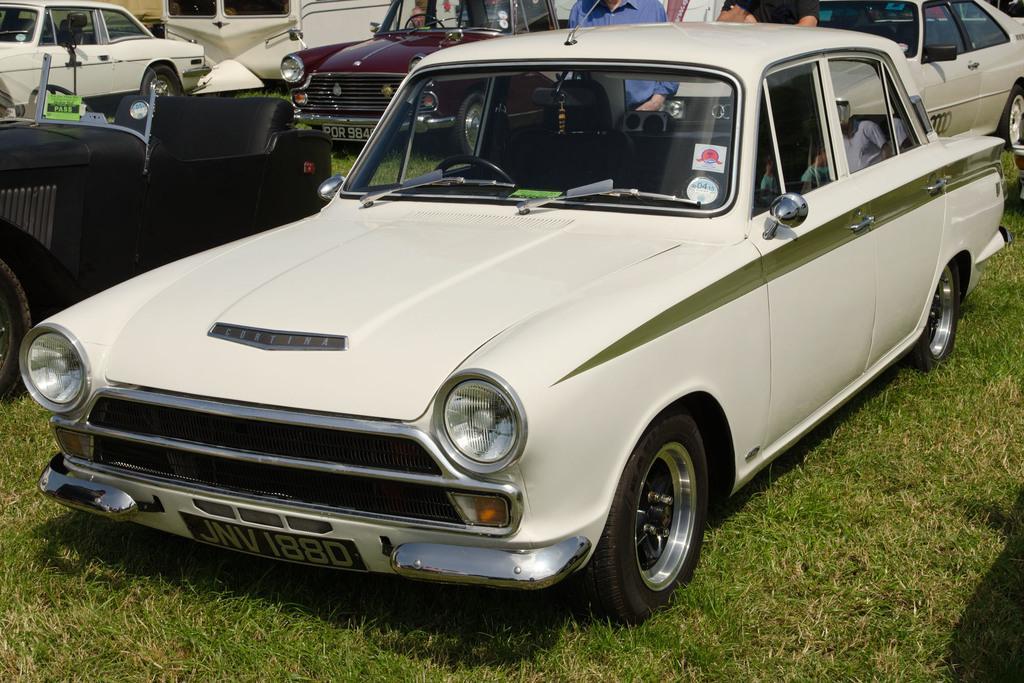Can you describe this image briefly? In this image we can see a number of cars. In the middle of the image white color car is there with the number JVV1880. And on the left side of the image consists black color car and behind that we can see the white color car. And at the middle back side we can see the maroon color car and right top side, we can see the white color car. A man standing behind the first car. The foreground is with the green grass. 